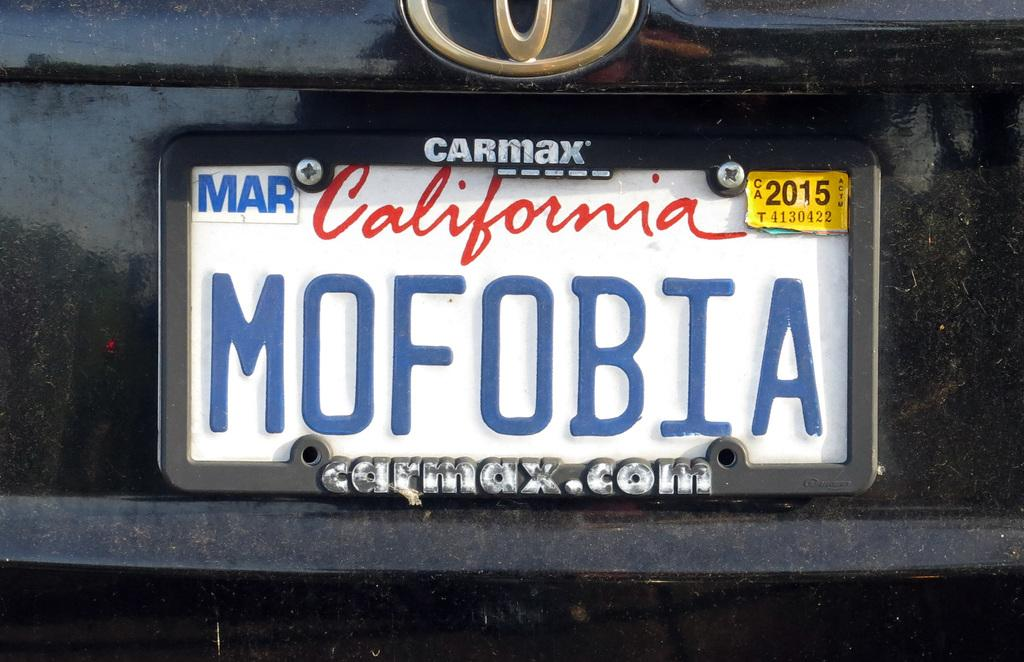<image>
Describe the image concisely. A California license plate with a carmax holder. 